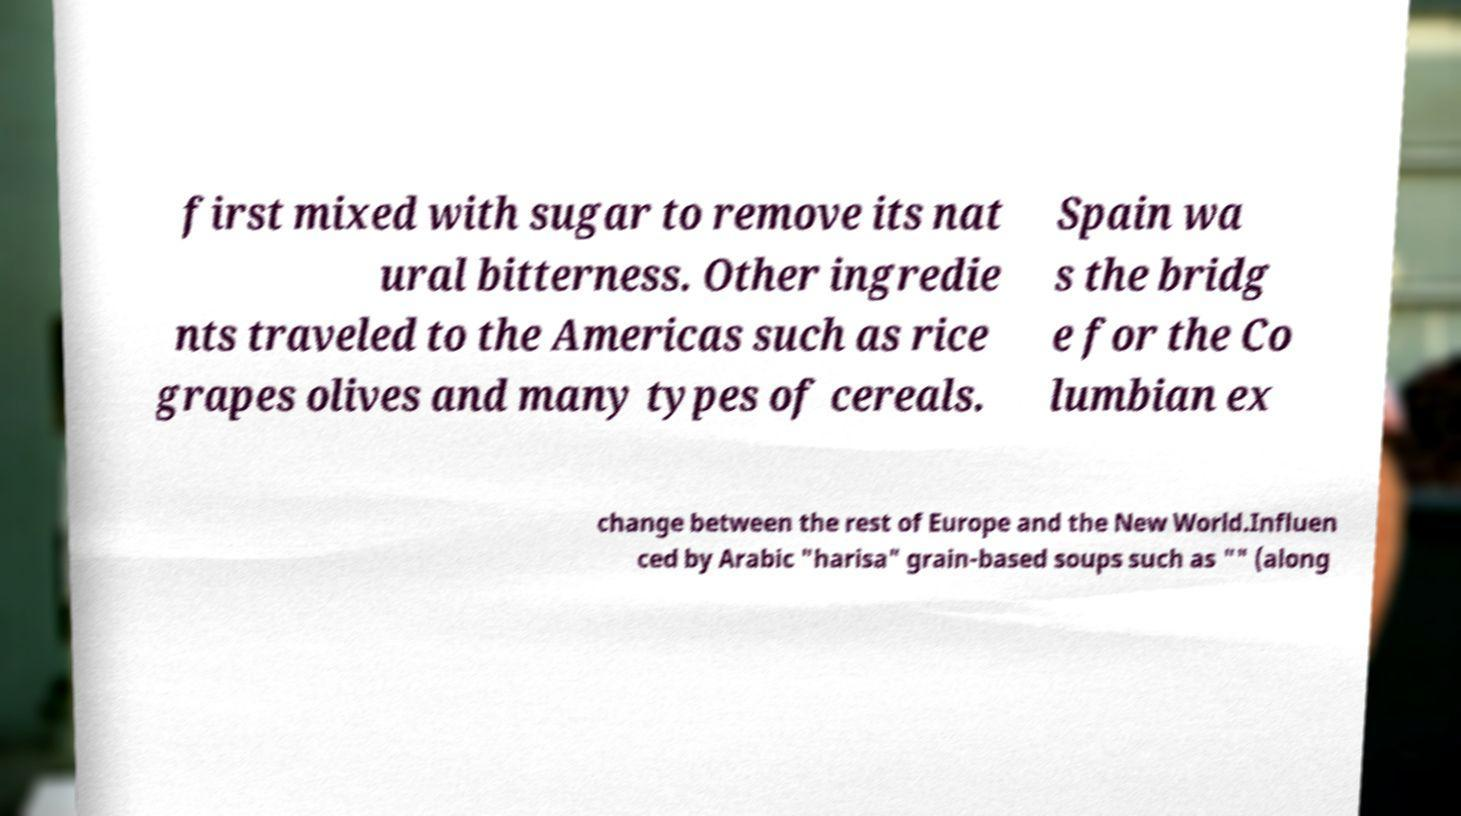There's text embedded in this image that I need extracted. Can you transcribe it verbatim? first mixed with sugar to remove its nat ural bitterness. Other ingredie nts traveled to the Americas such as rice grapes olives and many types of cereals. Spain wa s the bridg e for the Co lumbian ex change between the rest of Europe and the New World.Influen ced by Arabic "harisa" grain-based soups such as "" (along 